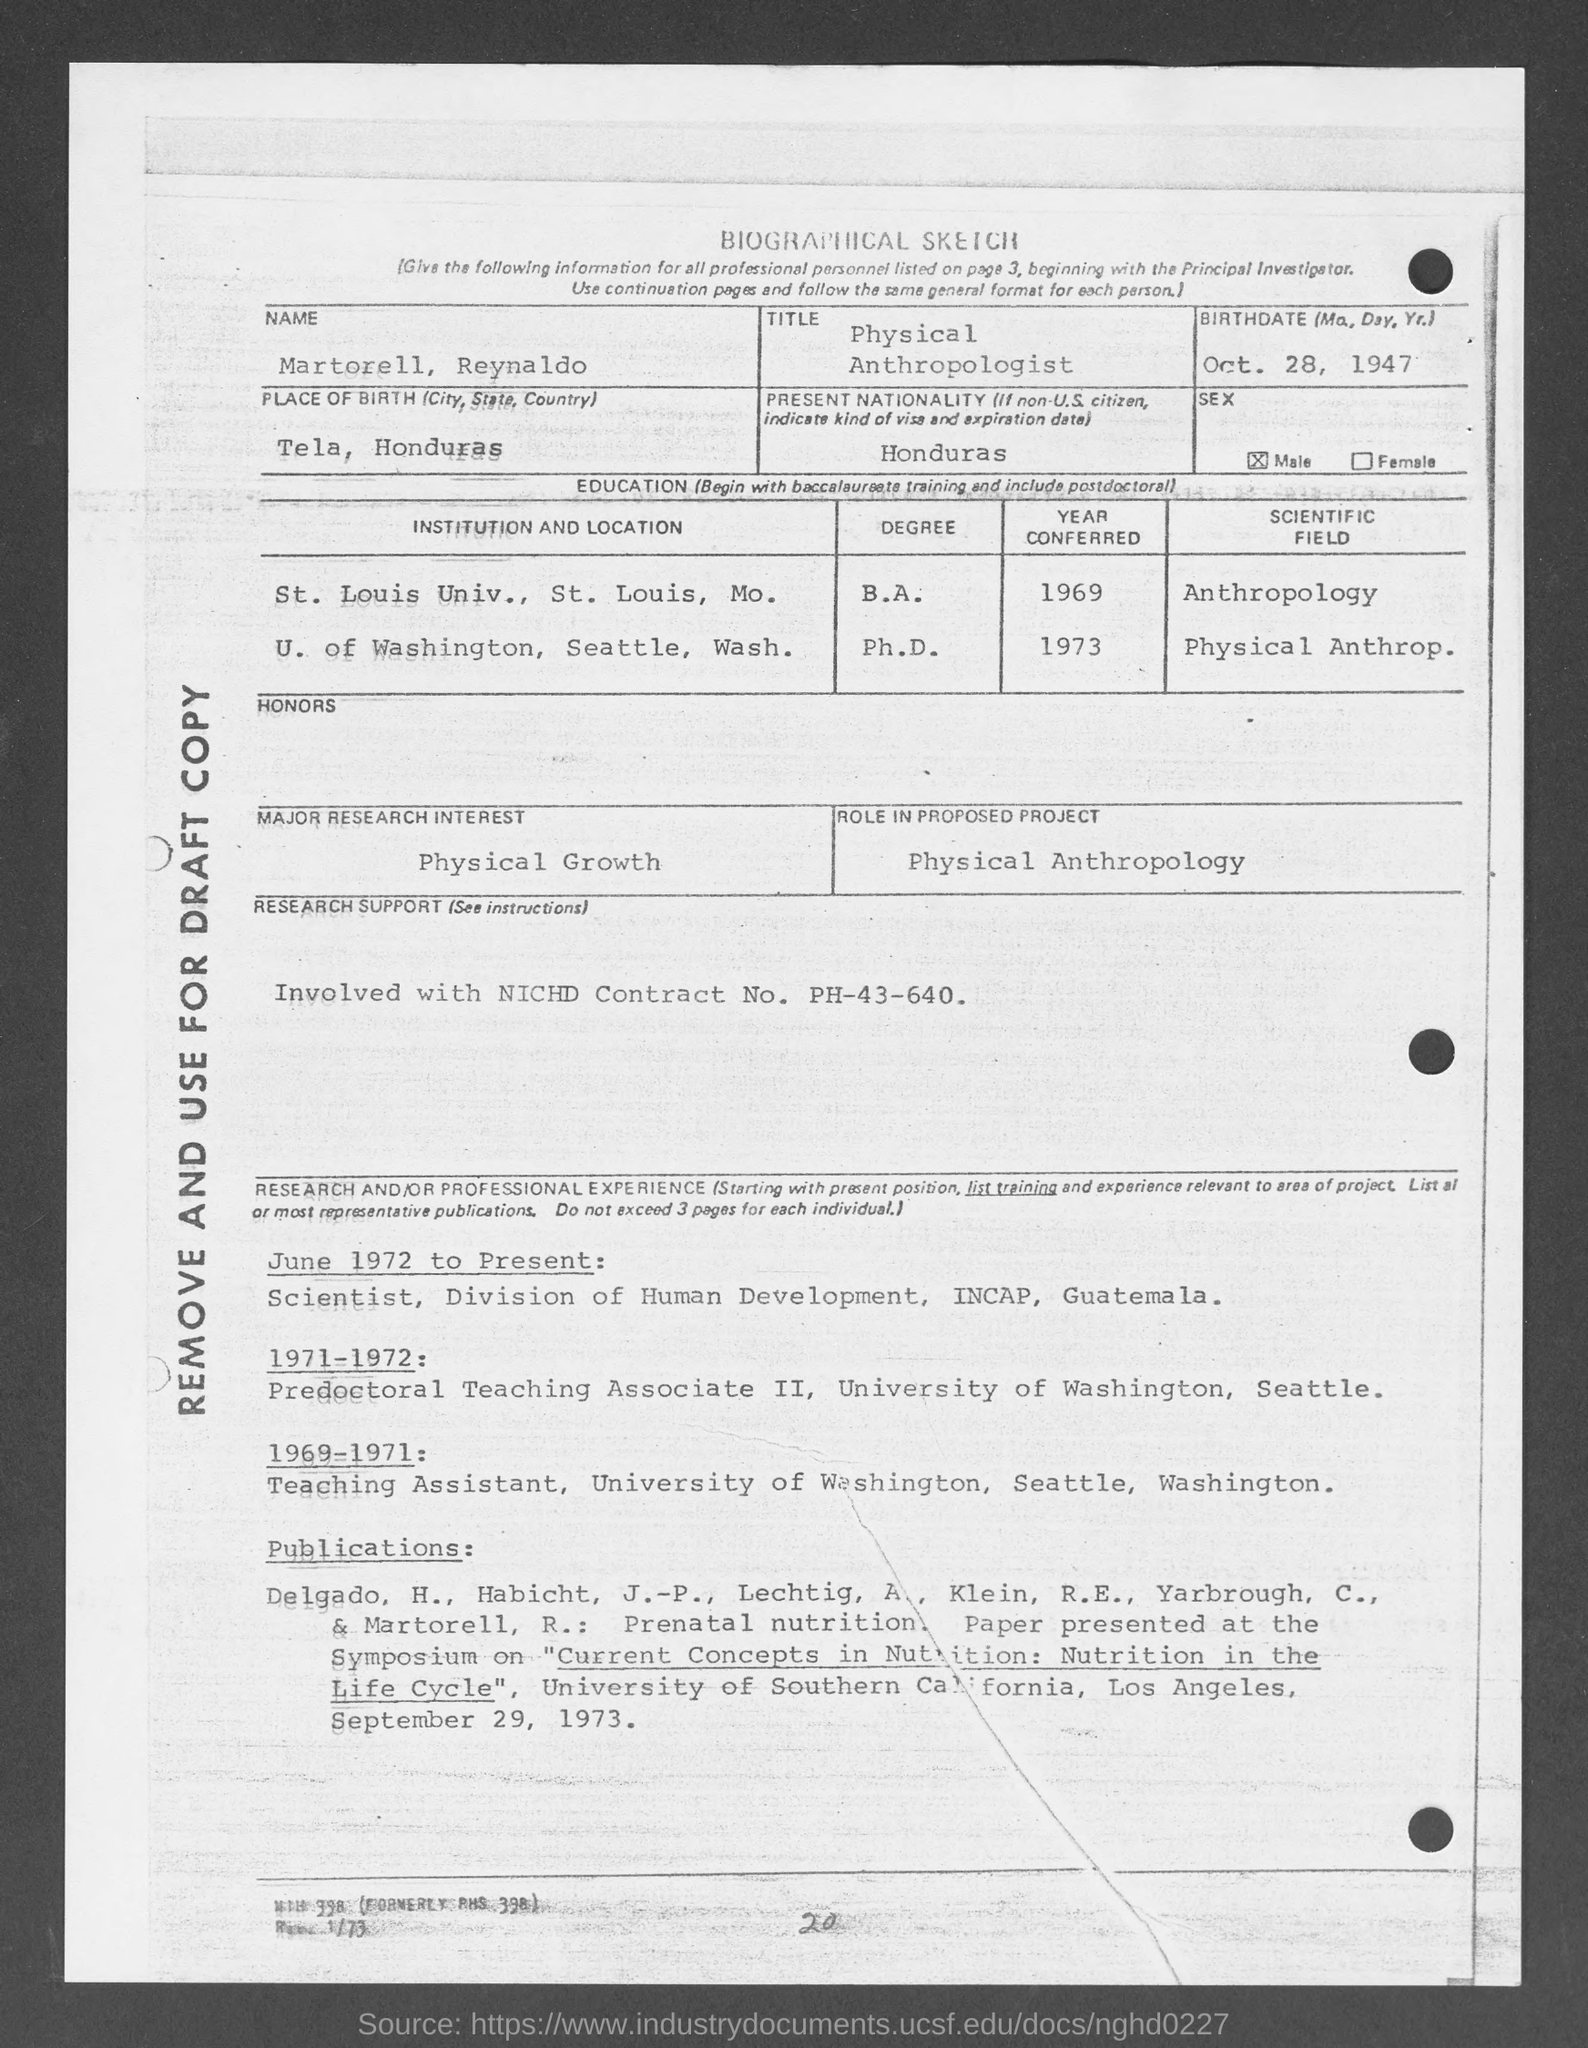Outline some significant characteristics in this image. The place of birth mentioned in the given sketch is Tel Aviv. The sex mentioned in the given sketch is male. The proposed project, as outlined in the given sketch, will involve the utilization of physical anthropology in order to further our understanding of the role of the human body in various activities and experiences. The major research interest mentioned in the given sketch is physical growth. The current nationality mentioned in the provided sketch is Honduras. 